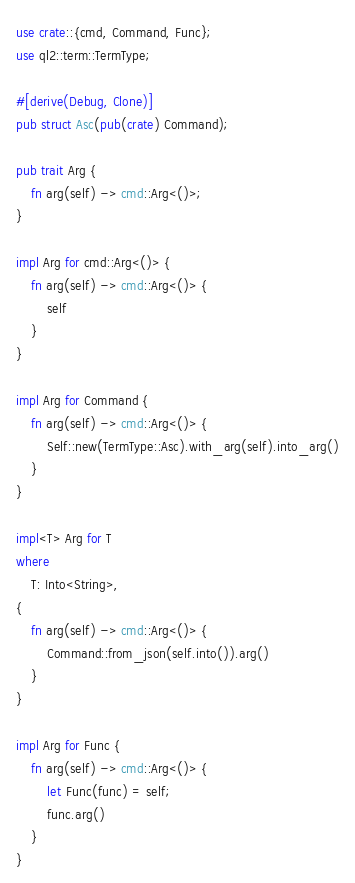<code> <loc_0><loc_0><loc_500><loc_500><_Rust_>use crate::{cmd, Command, Func};
use ql2::term::TermType;

#[derive(Debug, Clone)]
pub struct Asc(pub(crate) Command);

pub trait Arg {
    fn arg(self) -> cmd::Arg<()>;
}

impl Arg for cmd::Arg<()> {
    fn arg(self) -> cmd::Arg<()> {
        self
    }
}

impl Arg for Command {
    fn arg(self) -> cmd::Arg<()> {
        Self::new(TermType::Asc).with_arg(self).into_arg()
    }
}

impl<T> Arg for T
where
    T: Into<String>,
{
    fn arg(self) -> cmd::Arg<()> {
        Command::from_json(self.into()).arg()
    }
}

impl Arg for Func {
    fn arg(self) -> cmd::Arg<()> {
        let Func(func) = self;
        func.arg()
    }
}
</code> 